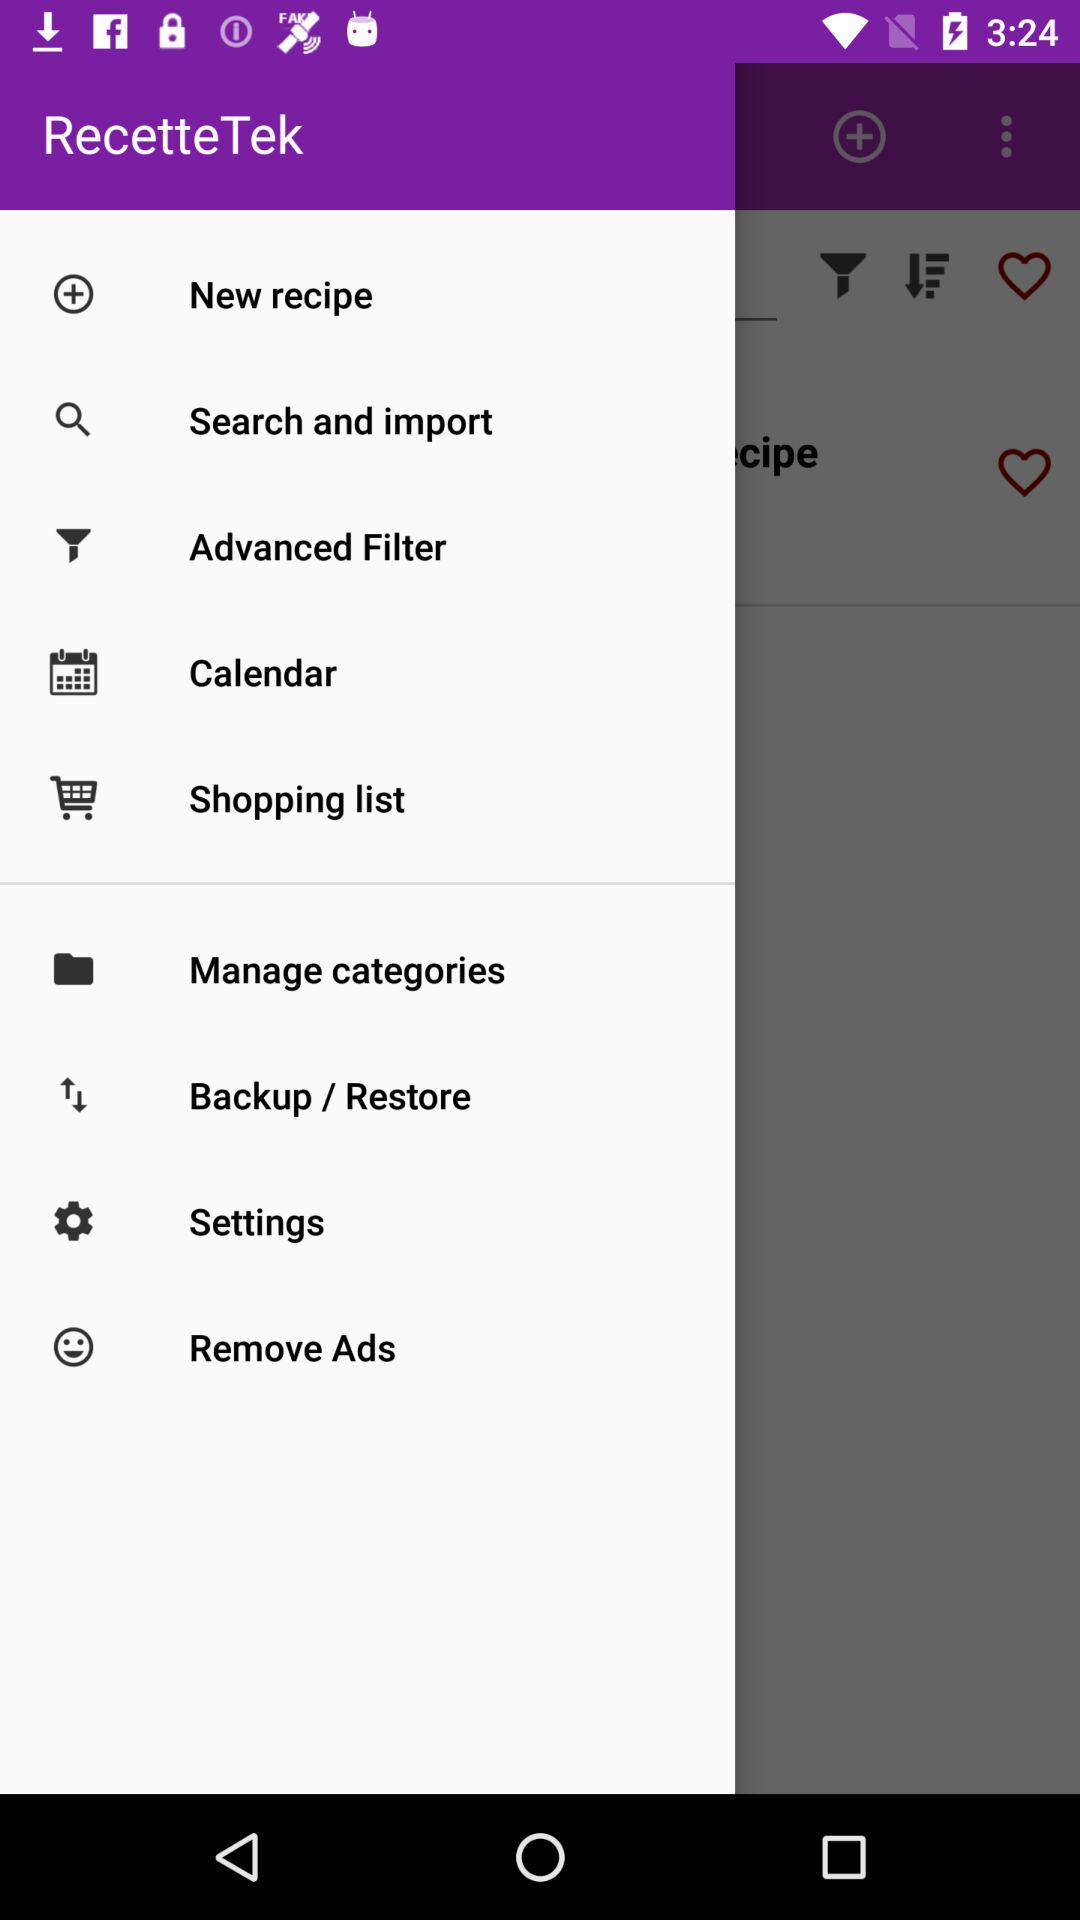What is the name of the application? The name of the application is "RecetteTek". 